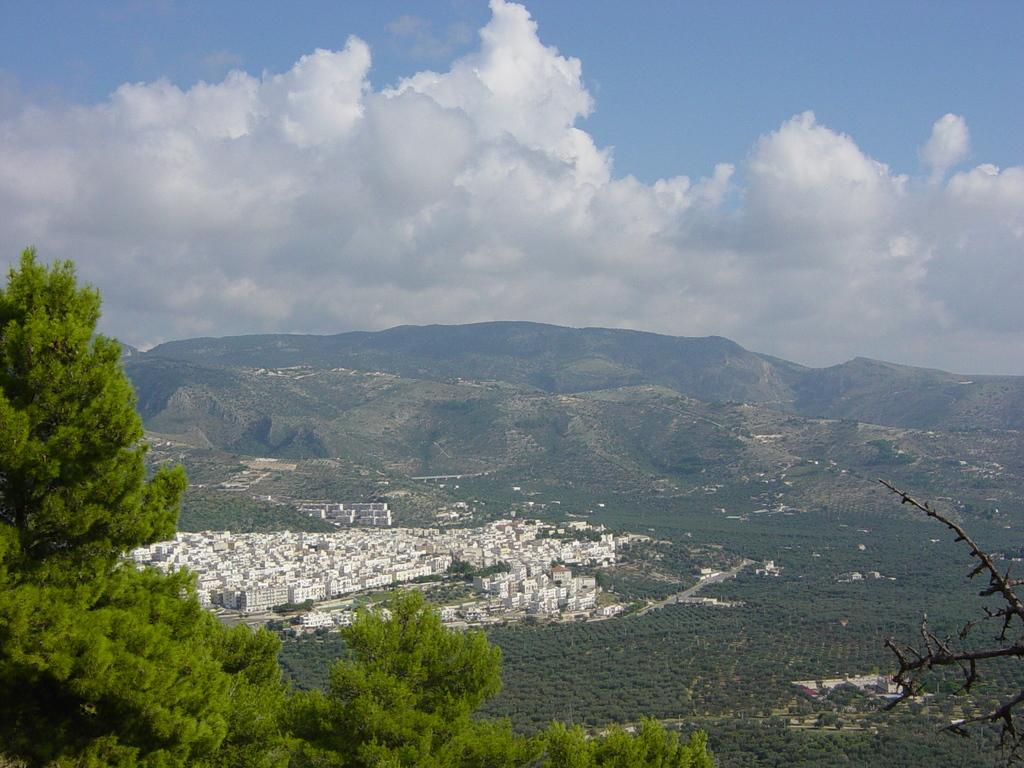What type of vegetation is in the foreground of the image? There are trees in the foreground of the image. What type of natural landmarks can be seen in the background of the image? There are mountains in the background of the image. What type of man-made structures are visible in the background of the image? There are buildings in the background of the image. What type of vegetation is also present in the background of the image? There are trees in the background of the image. What is visible at the top of the image? The sky is visible at the top of the image. Where is the kettle located in the image? There is no kettle present in the image. What type of secretary is visible in the image? There is no secretary present in the image. 